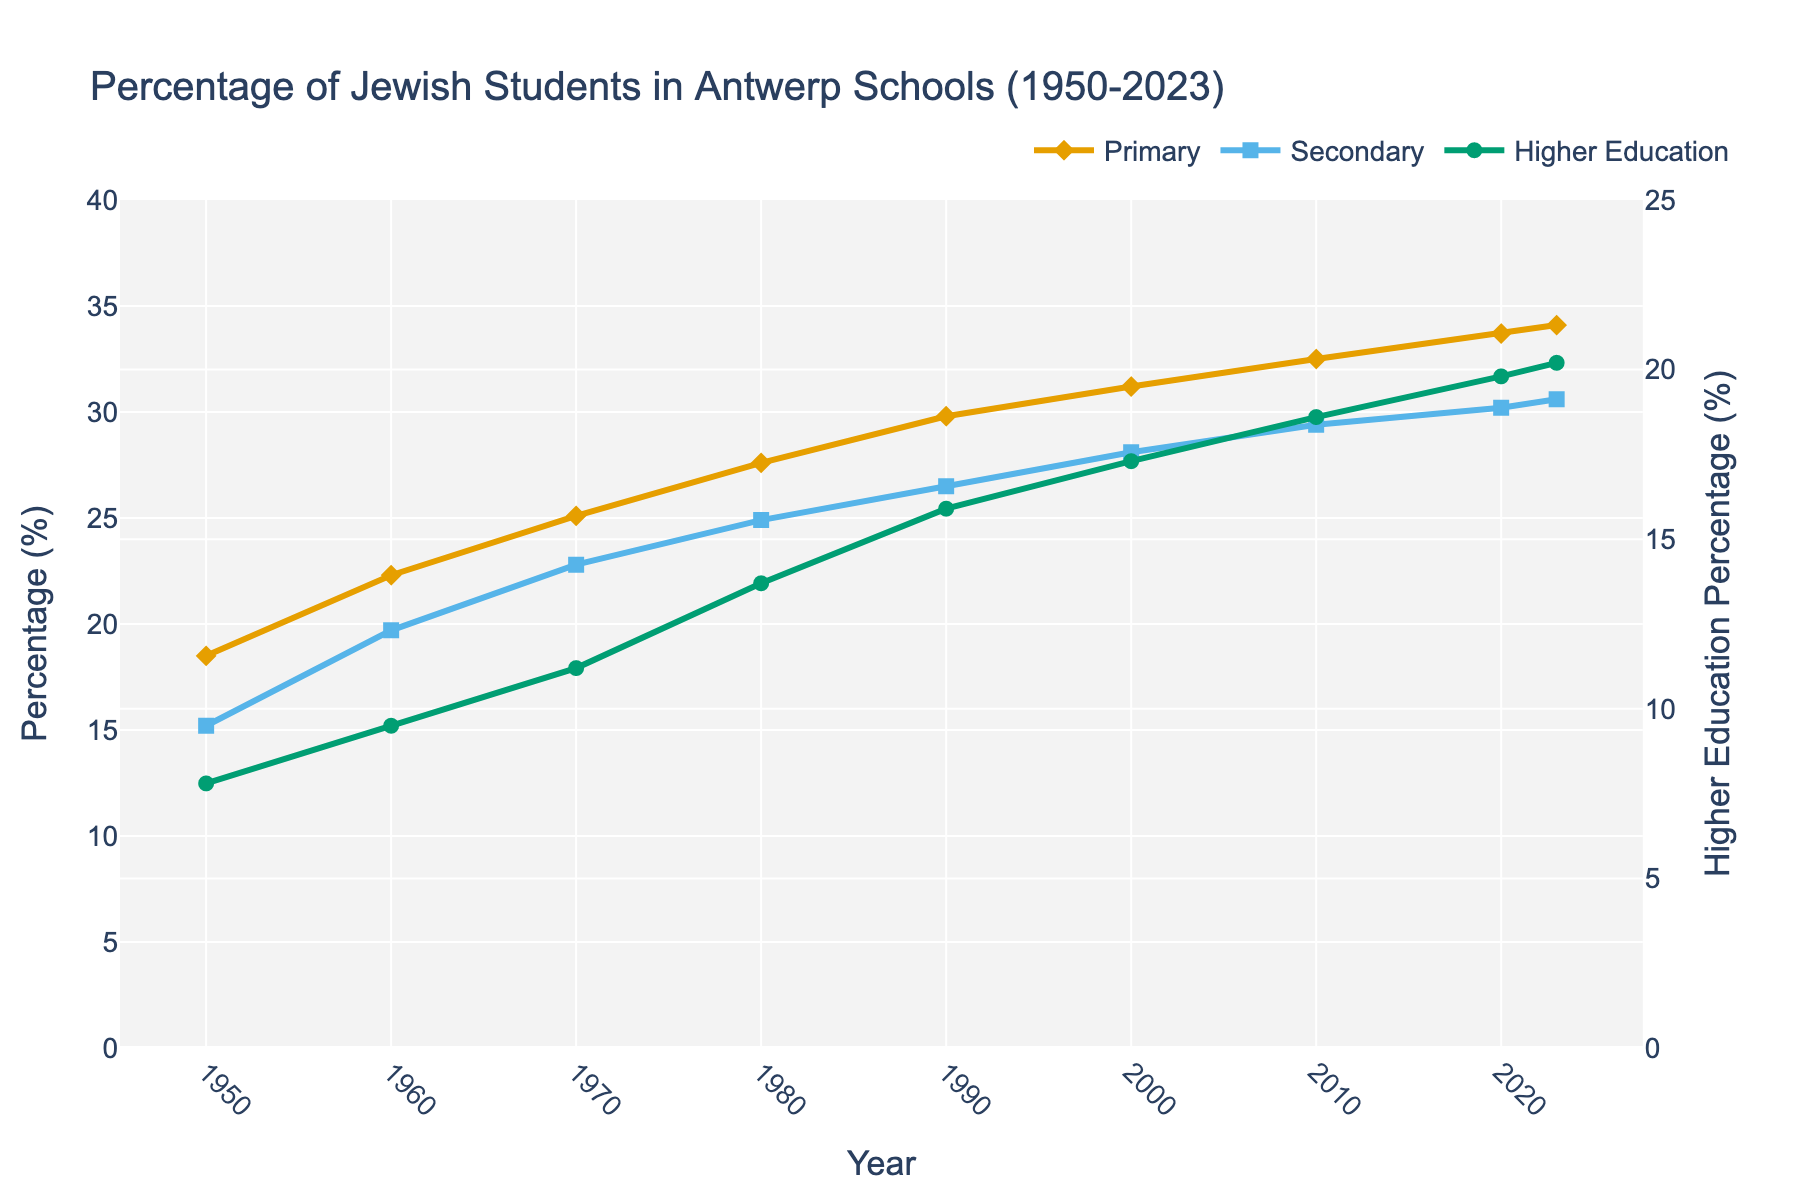What's the percentage increase of Jewish students in primary schools from 1950 to 2023? Subtract the percentage in 1950 from the percentage in 2023 for primary education: 34.1% - 18.5% = 15.6%
Answer: 15.6% Which education level shows the highest percentage of Jewish students in 2023? Refer to the year 2023 and compare the percentages for primary, secondary, and higher education. The highest percentage is in primary education at 34.1%.
Answer: Primary How has the percentage of Jewish students in secondary schools changed from 1980 to 2000? Subtract the percentage in 1980 from the percentage in 2000 for secondary education: 28.1% - 24.9% = 3.2%
Answer: Increased by 3.2% Among the three education levels, which one had the smallest percentage of Jewish students in 1950? Refer to the year 1950 and compare the percentages for primary, secondary, and higher education. The lowest percentage is in higher education at 7.8%.
Answer: Higher Education Calculate the average percentage of Jewish students in secondary schools over all the years presented. Sum the percentages for secondary education and divide by the number of years presented: (15.2% + 19.7% + 22.8% + 24.9% + 26.5% + 28.1% + 29.4% + 30.2% + 30.6%) / 9 ≈  24.1%
Answer: 24.1% Which trace uses markers shaped like diamonds in the line chart? Refer to the visual attributes of the traces. The primary education trace uses markers shaped like diamonds.
Answer: Primary Compare the percentage of Jewish students in higher education to secondary education in 2020. Is it higher or lower? Refer to the year 2020 and compare the percentages: higher education is at 19.8%, secondary education is at 30.2%. Higher education is lower.
Answer: Lower Identify the year with the lowest percentage of Jewish students in higher education from 1950 to present. Refer to the data series for higher education and identify the lowest value, which is in 1950 at 7.8%.
Answer: 1950 